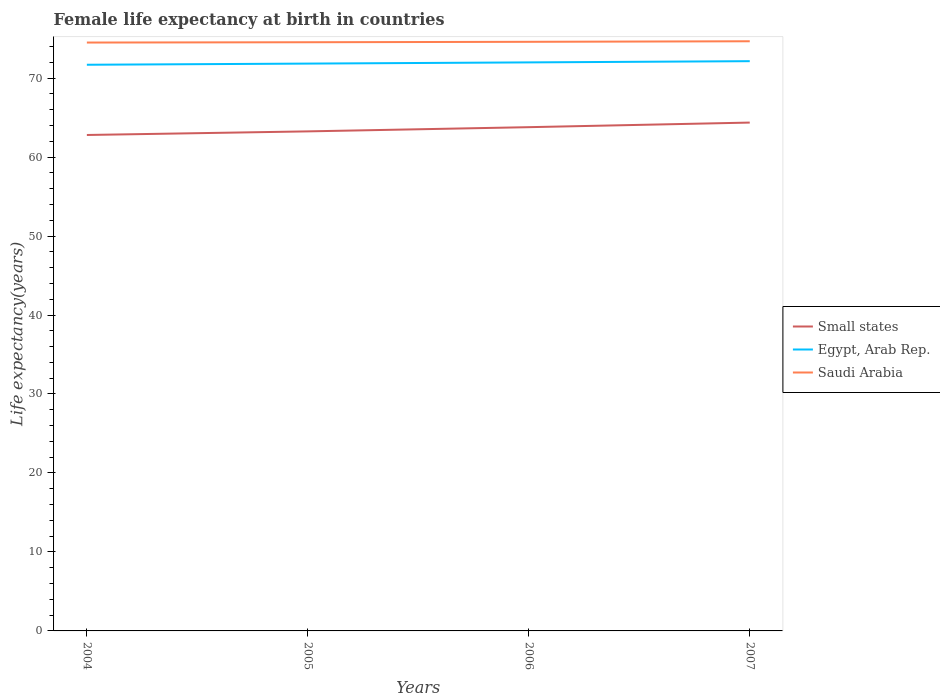Across all years, what is the maximum female life expectancy at birth in Egypt, Arab Rep.?
Give a very brief answer. 71.69. What is the total female life expectancy at birth in Small states in the graph?
Provide a short and direct response. -0.53. What is the difference between the highest and the second highest female life expectancy at birth in Saudi Arabia?
Your response must be concise. 0.16. Are the values on the major ticks of Y-axis written in scientific E-notation?
Provide a succinct answer. No. Does the graph contain any zero values?
Give a very brief answer. No. Does the graph contain grids?
Provide a succinct answer. No. Where does the legend appear in the graph?
Give a very brief answer. Center right. How many legend labels are there?
Your answer should be very brief. 3. What is the title of the graph?
Provide a succinct answer. Female life expectancy at birth in countries. What is the label or title of the Y-axis?
Ensure brevity in your answer.  Life expectancy(years). What is the Life expectancy(years) of Small states in 2004?
Offer a terse response. 62.8. What is the Life expectancy(years) in Egypt, Arab Rep. in 2004?
Offer a terse response. 71.69. What is the Life expectancy(years) in Saudi Arabia in 2004?
Your answer should be compact. 74.5. What is the Life expectancy(years) of Small states in 2005?
Your answer should be compact. 63.25. What is the Life expectancy(years) in Egypt, Arab Rep. in 2005?
Provide a short and direct response. 71.84. What is the Life expectancy(years) in Saudi Arabia in 2005?
Give a very brief answer. 74.54. What is the Life expectancy(years) in Small states in 2006?
Provide a short and direct response. 63.79. What is the Life expectancy(years) in Egypt, Arab Rep. in 2006?
Make the answer very short. 71.99. What is the Life expectancy(years) in Saudi Arabia in 2006?
Your response must be concise. 74.59. What is the Life expectancy(years) of Small states in 2007?
Provide a short and direct response. 64.37. What is the Life expectancy(years) in Egypt, Arab Rep. in 2007?
Your answer should be compact. 72.14. What is the Life expectancy(years) of Saudi Arabia in 2007?
Your response must be concise. 74.67. Across all years, what is the maximum Life expectancy(years) of Small states?
Provide a succinct answer. 64.37. Across all years, what is the maximum Life expectancy(years) of Egypt, Arab Rep.?
Keep it short and to the point. 72.14. Across all years, what is the maximum Life expectancy(years) in Saudi Arabia?
Make the answer very short. 74.67. Across all years, what is the minimum Life expectancy(years) in Small states?
Keep it short and to the point. 62.8. Across all years, what is the minimum Life expectancy(years) of Egypt, Arab Rep.?
Provide a short and direct response. 71.69. Across all years, what is the minimum Life expectancy(years) of Saudi Arabia?
Give a very brief answer. 74.5. What is the total Life expectancy(years) of Small states in the graph?
Keep it short and to the point. 254.21. What is the total Life expectancy(years) of Egypt, Arab Rep. in the graph?
Make the answer very short. 287.66. What is the total Life expectancy(years) of Saudi Arabia in the graph?
Keep it short and to the point. 298.3. What is the difference between the Life expectancy(years) in Small states in 2004 and that in 2005?
Provide a short and direct response. -0.46. What is the difference between the Life expectancy(years) in Egypt, Arab Rep. in 2004 and that in 2005?
Give a very brief answer. -0.15. What is the difference between the Life expectancy(years) in Saudi Arabia in 2004 and that in 2005?
Ensure brevity in your answer.  -0.04. What is the difference between the Life expectancy(years) in Small states in 2004 and that in 2006?
Offer a terse response. -0.99. What is the difference between the Life expectancy(years) in Egypt, Arab Rep. in 2004 and that in 2006?
Provide a succinct answer. -0.3. What is the difference between the Life expectancy(years) in Saudi Arabia in 2004 and that in 2006?
Offer a very short reply. -0.09. What is the difference between the Life expectancy(years) in Small states in 2004 and that in 2007?
Keep it short and to the point. -1.57. What is the difference between the Life expectancy(years) of Egypt, Arab Rep. in 2004 and that in 2007?
Your answer should be very brief. -0.45. What is the difference between the Life expectancy(years) of Saudi Arabia in 2004 and that in 2007?
Offer a terse response. -0.16. What is the difference between the Life expectancy(years) of Small states in 2005 and that in 2006?
Your response must be concise. -0.53. What is the difference between the Life expectancy(years) of Egypt, Arab Rep. in 2005 and that in 2006?
Make the answer very short. -0.15. What is the difference between the Life expectancy(years) in Saudi Arabia in 2005 and that in 2006?
Provide a short and direct response. -0.05. What is the difference between the Life expectancy(years) in Small states in 2005 and that in 2007?
Ensure brevity in your answer.  -1.11. What is the difference between the Life expectancy(years) of Egypt, Arab Rep. in 2005 and that in 2007?
Ensure brevity in your answer.  -0.31. What is the difference between the Life expectancy(years) in Saudi Arabia in 2005 and that in 2007?
Keep it short and to the point. -0.12. What is the difference between the Life expectancy(years) of Small states in 2006 and that in 2007?
Your answer should be very brief. -0.58. What is the difference between the Life expectancy(years) of Egypt, Arab Rep. in 2006 and that in 2007?
Your response must be concise. -0.15. What is the difference between the Life expectancy(years) of Saudi Arabia in 2006 and that in 2007?
Provide a succinct answer. -0.07. What is the difference between the Life expectancy(years) of Small states in 2004 and the Life expectancy(years) of Egypt, Arab Rep. in 2005?
Offer a very short reply. -9.04. What is the difference between the Life expectancy(years) in Small states in 2004 and the Life expectancy(years) in Saudi Arabia in 2005?
Offer a terse response. -11.74. What is the difference between the Life expectancy(years) in Egypt, Arab Rep. in 2004 and the Life expectancy(years) in Saudi Arabia in 2005?
Your answer should be very brief. -2.85. What is the difference between the Life expectancy(years) of Small states in 2004 and the Life expectancy(years) of Egypt, Arab Rep. in 2006?
Offer a terse response. -9.19. What is the difference between the Life expectancy(years) of Small states in 2004 and the Life expectancy(years) of Saudi Arabia in 2006?
Ensure brevity in your answer.  -11.8. What is the difference between the Life expectancy(years) of Egypt, Arab Rep. in 2004 and the Life expectancy(years) of Saudi Arabia in 2006?
Your response must be concise. -2.9. What is the difference between the Life expectancy(years) in Small states in 2004 and the Life expectancy(years) in Egypt, Arab Rep. in 2007?
Your answer should be compact. -9.35. What is the difference between the Life expectancy(years) in Small states in 2004 and the Life expectancy(years) in Saudi Arabia in 2007?
Provide a succinct answer. -11.87. What is the difference between the Life expectancy(years) of Egypt, Arab Rep. in 2004 and the Life expectancy(years) of Saudi Arabia in 2007?
Offer a terse response. -2.98. What is the difference between the Life expectancy(years) of Small states in 2005 and the Life expectancy(years) of Egypt, Arab Rep. in 2006?
Make the answer very short. -8.73. What is the difference between the Life expectancy(years) in Small states in 2005 and the Life expectancy(years) in Saudi Arabia in 2006?
Your answer should be compact. -11.34. What is the difference between the Life expectancy(years) of Egypt, Arab Rep. in 2005 and the Life expectancy(years) of Saudi Arabia in 2006?
Offer a very short reply. -2.76. What is the difference between the Life expectancy(years) of Small states in 2005 and the Life expectancy(years) of Egypt, Arab Rep. in 2007?
Make the answer very short. -8.89. What is the difference between the Life expectancy(years) in Small states in 2005 and the Life expectancy(years) in Saudi Arabia in 2007?
Provide a short and direct response. -11.41. What is the difference between the Life expectancy(years) of Egypt, Arab Rep. in 2005 and the Life expectancy(years) of Saudi Arabia in 2007?
Give a very brief answer. -2.83. What is the difference between the Life expectancy(years) in Small states in 2006 and the Life expectancy(years) in Egypt, Arab Rep. in 2007?
Your answer should be compact. -8.36. What is the difference between the Life expectancy(years) of Small states in 2006 and the Life expectancy(years) of Saudi Arabia in 2007?
Your response must be concise. -10.88. What is the difference between the Life expectancy(years) in Egypt, Arab Rep. in 2006 and the Life expectancy(years) in Saudi Arabia in 2007?
Your answer should be very brief. -2.68. What is the average Life expectancy(years) of Small states per year?
Keep it short and to the point. 63.55. What is the average Life expectancy(years) in Egypt, Arab Rep. per year?
Give a very brief answer. 71.91. What is the average Life expectancy(years) of Saudi Arabia per year?
Make the answer very short. 74.58. In the year 2004, what is the difference between the Life expectancy(years) in Small states and Life expectancy(years) in Egypt, Arab Rep.?
Make the answer very short. -8.89. In the year 2004, what is the difference between the Life expectancy(years) in Small states and Life expectancy(years) in Saudi Arabia?
Offer a terse response. -11.71. In the year 2004, what is the difference between the Life expectancy(years) in Egypt, Arab Rep. and Life expectancy(years) in Saudi Arabia?
Make the answer very short. -2.81. In the year 2005, what is the difference between the Life expectancy(years) of Small states and Life expectancy(years) of Egypt, Arab Rep.?
Keep it short and to the point. -8.58. In the year 2005, what is the difference between the Life expectancy(years) in Small states and Life expectancy(years) in Saudi Arabia?
Make the answer very short. -11.29. In the year 2005, what is the difference between the Life expectancy(years) of Egypt, Arab Rep. and Life expectancy(years) of Saudi Arabia?
Your answer should be very brief. -2.71. In the year 2006, what is the difference between the Life expectancy(years) of Small states and Life expectancy(years) of Egypt, Arab Rep.?
Give a very brief answer. -8.2. In the year 2006, what is the difference between the Life expectancy(years) of Small states and Life expectancy(years) of Saudi Arabia?
Provide a succinct answer. -10.81. In the year 2006, what is the difference between the Life expectancy(years) in Egypt, Arab Rep. and Life expectancy(years) in Saudi Arabia?
Your response must be concise. -2.61. In the year 2007, what is the difference between the Life expectancy(years) in Small states and Life expectancy(years) in Egypt, Arab Rep.?
Provide a short and direct response. -7.78. In the year 2007, what is the difference between the Life expectancy(years) in Small states and Life expectancy(years) in Saudi Arabia?
Offer a very short reply. -10.3. In the year 2007, what is the difference between the Life expectancy(years) in Egypt, Arab Rep. and Life expectancy(years) in Saudi Arabia?
Offer a terse response. -2.52. What is the ratio of the Life expectancy(years) in Saudi Arabia in 2004 to that in 2005?
Ensure brevity in your answer.  1. What is the ratio of the Life expectancy(years) of Small states in 2004 to that in 2006?
Your answer should be compact. 0.98. What is the ratio of the Life expectancy(years) in Egypt, Arab Rep. in 2004 to that in 2006?
Offer a terse response. 1. What is the ratio of the Life expectancy(years) of Saudi Arabia in 2004 to that in 2006?
Offer a very short reply. 1. What is the ratio of the Life expectancy(years) in Small states in 2004 to that in 2007?
Make the answer very short. 0.98. What is the ratio of the Life expectancy(years) in Saudi Arabia in 2004 to that in 2007?
Your response must be concise. 1. What is the ratio of the Life expectancy(years) of Small states in 2005 to that in 2006?
Give a very brief answer. 0.99. What is the ratio of the Life expectancy(years) of Egypt, Arab Rep. in 2005 to that in 2006?
Keep it short and to the point. 1. What is the ratio of the Life expectancy(years) of Saudi Arabia in 2005 to that in 2006?
Offer a very short reply. 1. What is the ratio of the Life expectancy(years) of Small states in 2005 to that in 2007?
Give a very brief answer. 0.98. What is the ratio of the Life expectancy(years) in Saudi Arabia in 2006 to that in 2007?
Your response must be concise. 1. What is the difference between the highest and the second highest Life expectancy(years) of Small states?
Offer a very short reply. 0.58. What is the difference between the highest and the second highest Life expectancy(years) of Egypt, Arab Rep.?
Offer a terse response. 0.15. What is the difference between the highest and the second highest Life expectancy(years) of Saudi Arabia?
Give a very brief answer. 0.07. What is the difference between the highest and the lowest Life expectancy(years) of Small states?
Provide a short and direct response. 1.57. What is the difference between the highest and the lowest Life expectancy(years) of Egypt, Arab Rep.?
Offer a terse response. 0.45. What is the difference between the highest and the lowest Life expectancy(years) of Saudi Arabia?
Offer a terse response. 0.16. 